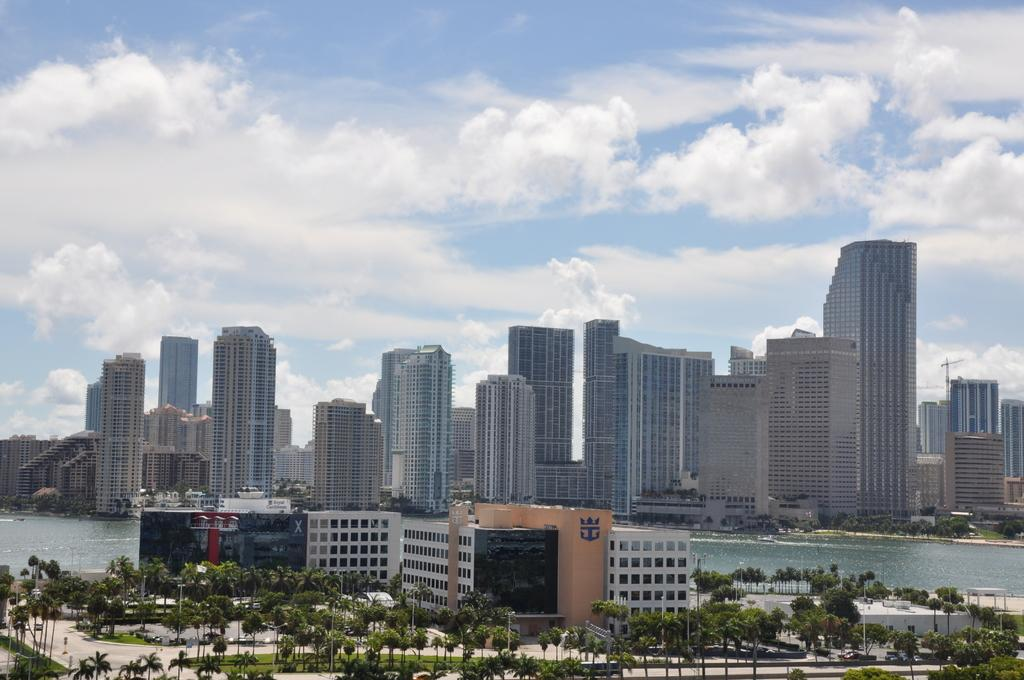What type of natural elements can be seen in the image? There are trees in the image. What type of man-made structures are visible in the image? There are buildings in the front and background of the image. What is the central feature in the middle of the image? There is water visible in the middle of the image. What can be seen in the background of the image? There are more buildings and the sky visible in the background of the image. How many clocks are hanging from the trees in the image? There are no clocks hanging from the trees in the image. What type of pocket can be seen on the water in the image? There is no pocket present in the image; it features trees, buildings, water, and the sky. 